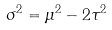<formula> <loc_0><loc_0><loc_500><loc_500>\sigma ^ { 2 } = \mu ^ { 2 } - 2 \tau ^ { 2 }</formula> 